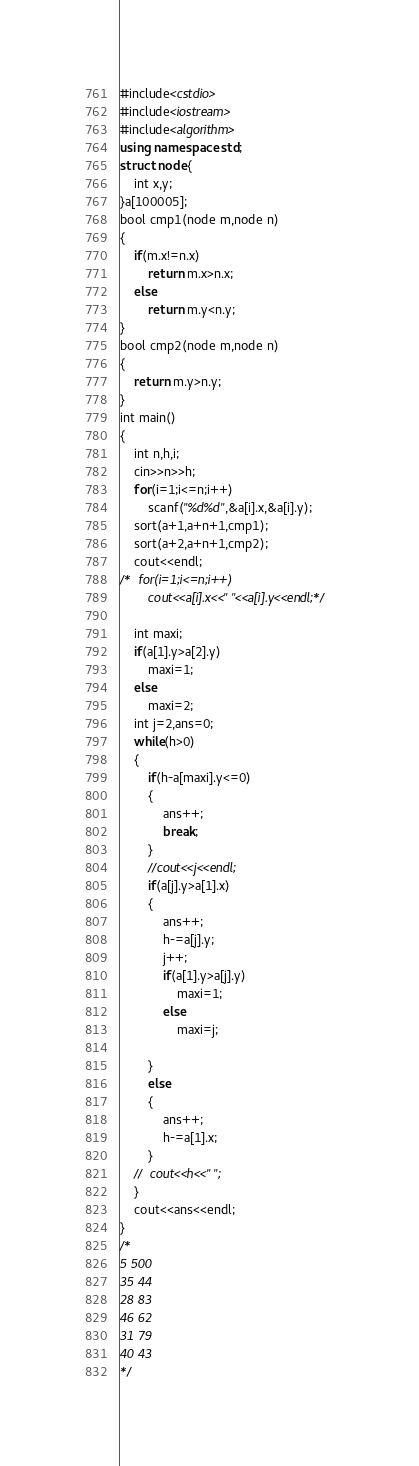Convert code to text. <code><loc_0><loc_0><loc_500><loc_500><_C++_>#include<cstdio>
#include<iostream>
#include<algorithm>
using namespace std;
struct node{
	int x,y;
}a[100005];
bool cmp1(node m,node n)
{
	if(m.x!=n.x)
		return m.x>n.x;
	else 
		return m.y<n.y;
}
bool cmp2(node m,node n)
{
	return m.y>n.y;
}
int main()
{
	int n,h,i;
	cin>>n>>h;
	for(i=1;i<=n;i++)
		scanf("%d%d",&a[i].x,&a[i].y);
	sort(a+1,a+n+1,cmp1);
	sort(a+2,a+n+1,cmp2);
	cout<<endl;
/*	for(i=1;i<=n;i++)
		cout<<a[i].x<<" "<<a[i].y<<endl;*/
		
	int maxi;
	if(a[1].y>a[2].y) 
		maxi=1;
	else 
		maxi=2;
	int j=2,ans=0;
	while(h>0)
	{
		if(h-a[maxi].y<=0)
		{
			ans++;
			break;
		}
		//cout<<j<<endl;
		if(a[j].y>a[1].x)
		{
			ans++;
			h-=a[j].y;
			j++;
			if(a[1].y>a[j].y) 
				maxi=1;
			else 
				maxi=j;
			
		}
		else 
		{
			ans++;
			h-=a[1].x;
		}
	//	cout<<h<<" ";
	}
	cout<<ans<<endl;
}
/*
5 500
35 44
28 83
46 62
31 79
40 43
*/</code> 